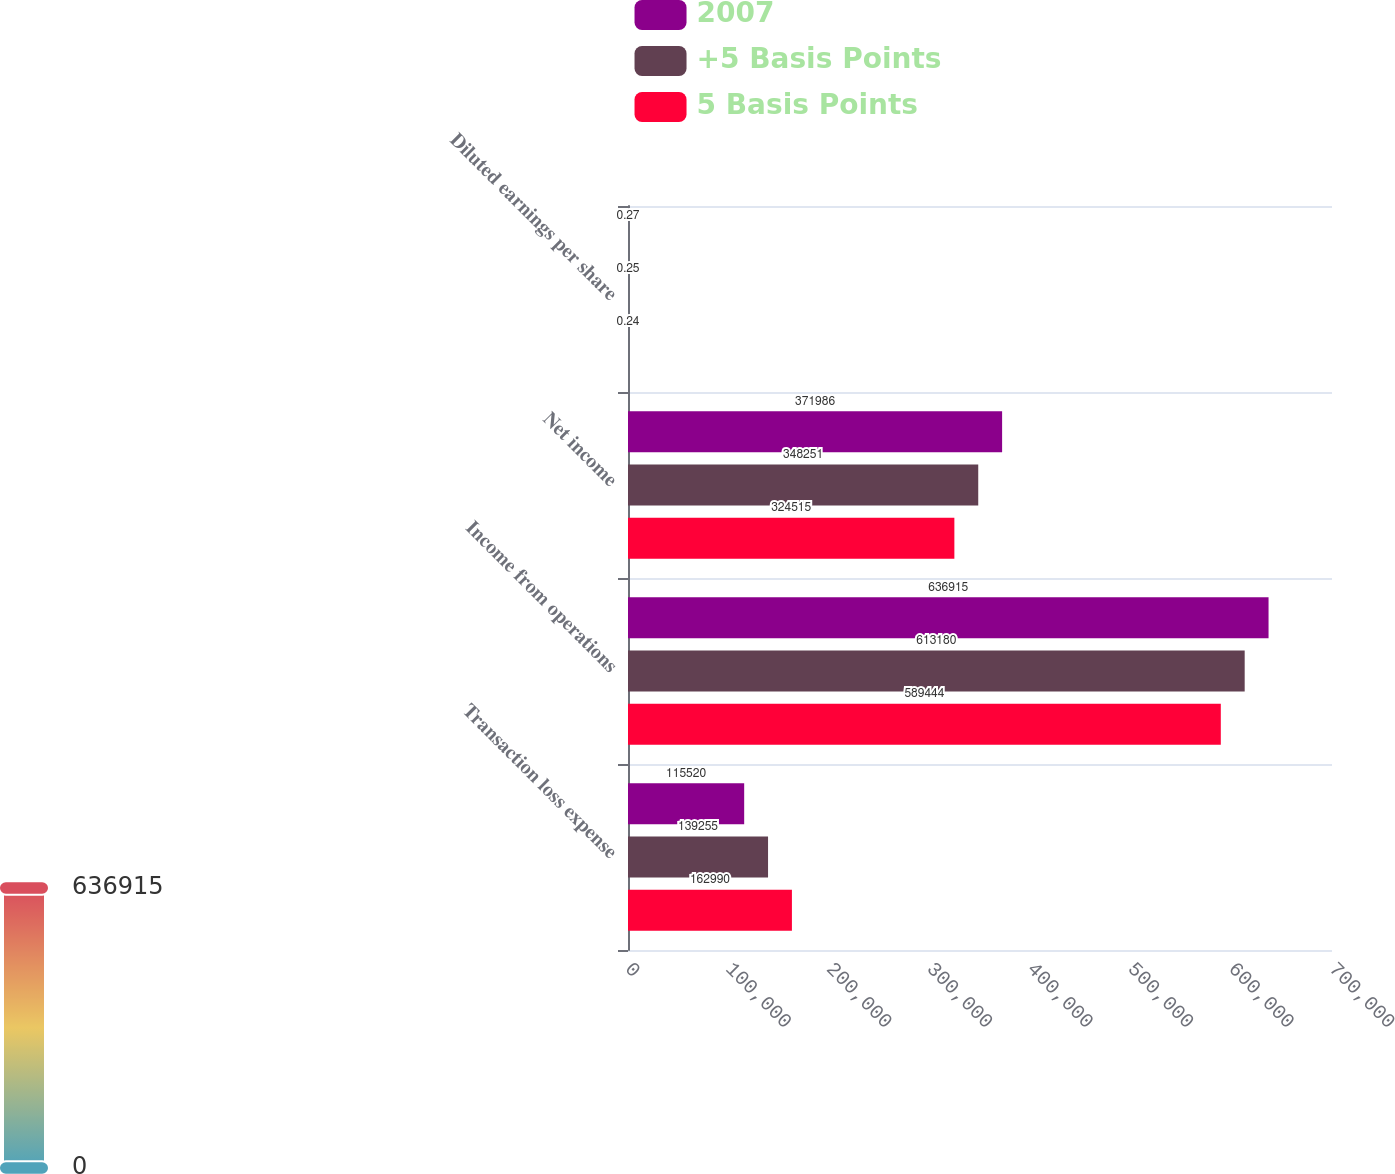<chart> <loc_0><loc_0><loc_500><loc_500><stacked_bar_chart><ecel><fcel>Transaction loss expense<fcel>Income from operations<fcel>Net income<fcel>Diluted earnings per share<nl><fcel>2007<fcel>115520<fcel>636915<fcel>371986<fcel>0.27<nl><fcel>+5 Basis Points<fcel>139255<fcel>613180<fcel>348251<fcel>0.25<nl><fcel>5 Basis Points<fcel>162990<fcel>589444<fcel>324515<fcel>0.24<nl></chart> 